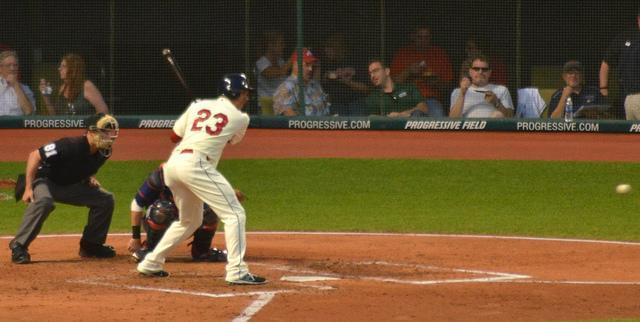How many people are there?
Give a very brief answer. 9. 